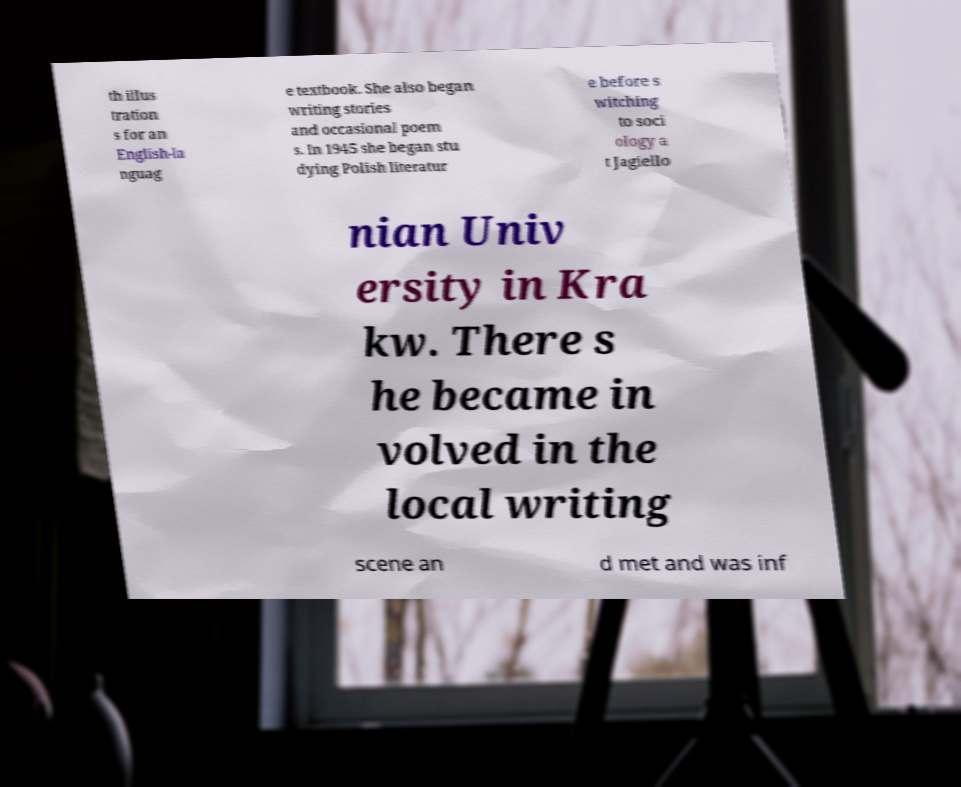Please read and relay the text visible in this image. What does it say? th illus tration s for an English-la nguag e textbook. She also began writing stories and occasional poem s. In 1945 she began stu dying Polish literatur e before s witching to soci ology a t Jagiello nian Univ ersity in Kra kw. There s he became in volved in the local writing scene an d met and was inf 